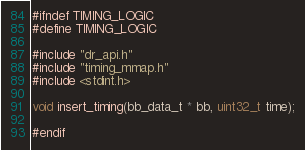<code> <loc_0><loc_0><loc_500><loc_500><_C_>#ifndef TIMING_LOGIC
#define TIMING_LOGIC

#include "dr_api.h"
#include "timing_mmap.h"
#include <stdint.h>

void insert_timing(bb_data_t * bb, uint32_t time);

#endif
</code> 